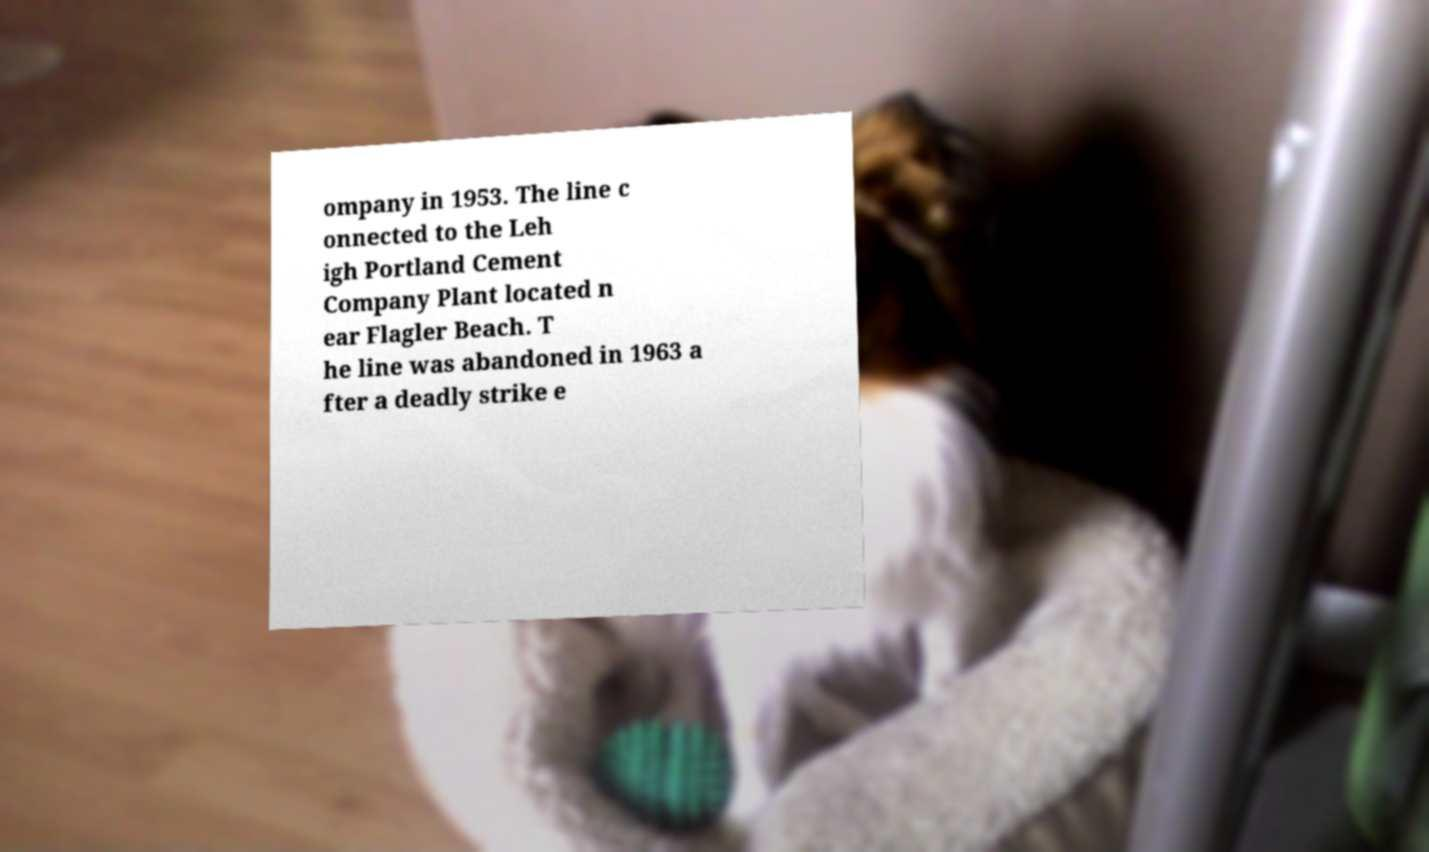There's text embedded in this image that I need extracted. Can you transcribe it verbatim? ompany in 1953. The line c onnected to the Leh igh Portland Cement Company Plant located n ear Flagler Beach. T he line was abandoned in 1963 a fter a deadly strike e 